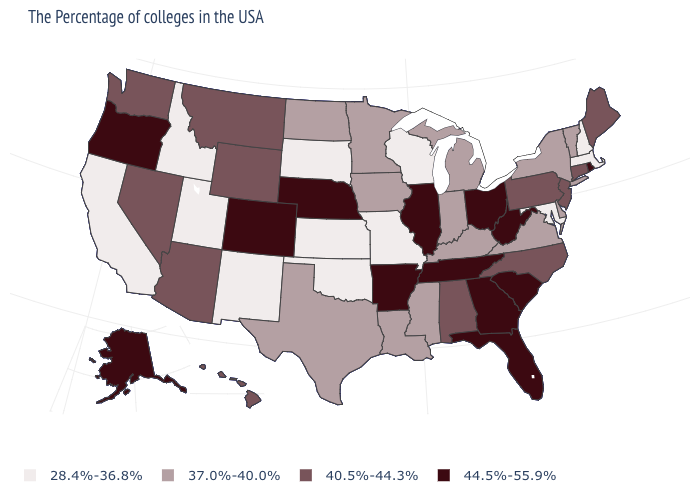What is the value of New Jersey?
Be succinct. 40.5%-44.3%. Is the legend a continuous bar?
Short answer required. No. Among the states that border Delaware , which have the lowest value?
Concise answer only. Maryland. Among the states that border North Carolina , which have the highest value?
Short answer required. South Carolina, Georgia, Tennessee. Name the states that have a value in the range 37.0%-40.0%?
Concise answer only. Vermont, New York, Delaware, Virginia, Michigan, Kentucky, Indiana, Mississippi, Louisiana, Minnesota, Iowa, Texas, North Dakota. Among the states that border Mississippi , which have the highest value?
Answer briefly. Tennessee, Arkansas. Does Connecticut have the lowest value in the USA?
Give a very brief answer. No. Name the states that have a value in the range 40.5%-44.3%?
Answer briefly. Maine, Connecticut, New Jersey, Pennsylvania, North Carolina, Alabama, Wyoming, Montana, Arizona, Nevada, Washington, Hawaii. Is the legend a continuous bar?
Concise answer only. No. Which states have the lowest value in the USA?
Be succinct. Massachusetts, New Hampshire, Maryland, Wisconsin, Missouri, Kansas, Oklahoma, South Dakota, New Mexico, Utah, Idaho, California. What is the highest value in the Northeast ?
Answer briefly. 44.5%-55.9%. Does the map have missing data?
Be succinct. No. Among the states that border Pennsylvania , does West Virginia have the highest value?
Keep it brief. Yes. 